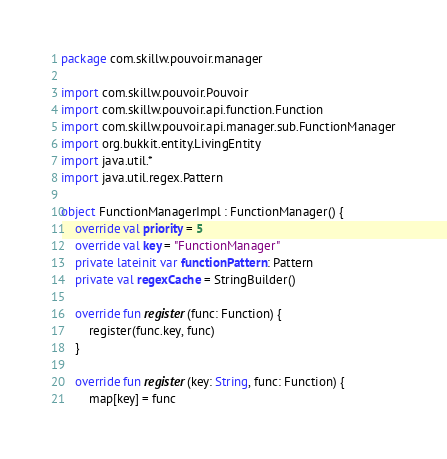<code> <loc_0><loc_0><loc_500><loc_500><_Kotlin_>package com.skillw.pouvoir.manager

import com.skillw.pouvoir.Pouvoir
import com.skillw.pouvoir.api.function.Function
import com.skillw.pouvoir.api.manager.sub.FunctionManager
import org.bukkit.entity.LivingEntity
import java.util.*
import java.util.regex.Pattern

object FunctionManagerImpl : FunctionManager() {
    override val priority = 5
    override val key = "FunctionManager"
    private lateinit var functionPattern: Pattern
    private val regexCache = StringBuilder()

    override fun register(func: Function) {
        register(func.key, func)
    }

    override fun register(key: String, func: Function) {
        map[key] = func</code> 